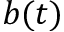<formula> <loc_0><loc_0><loc_500><loc_500>b ( t )</formula> 